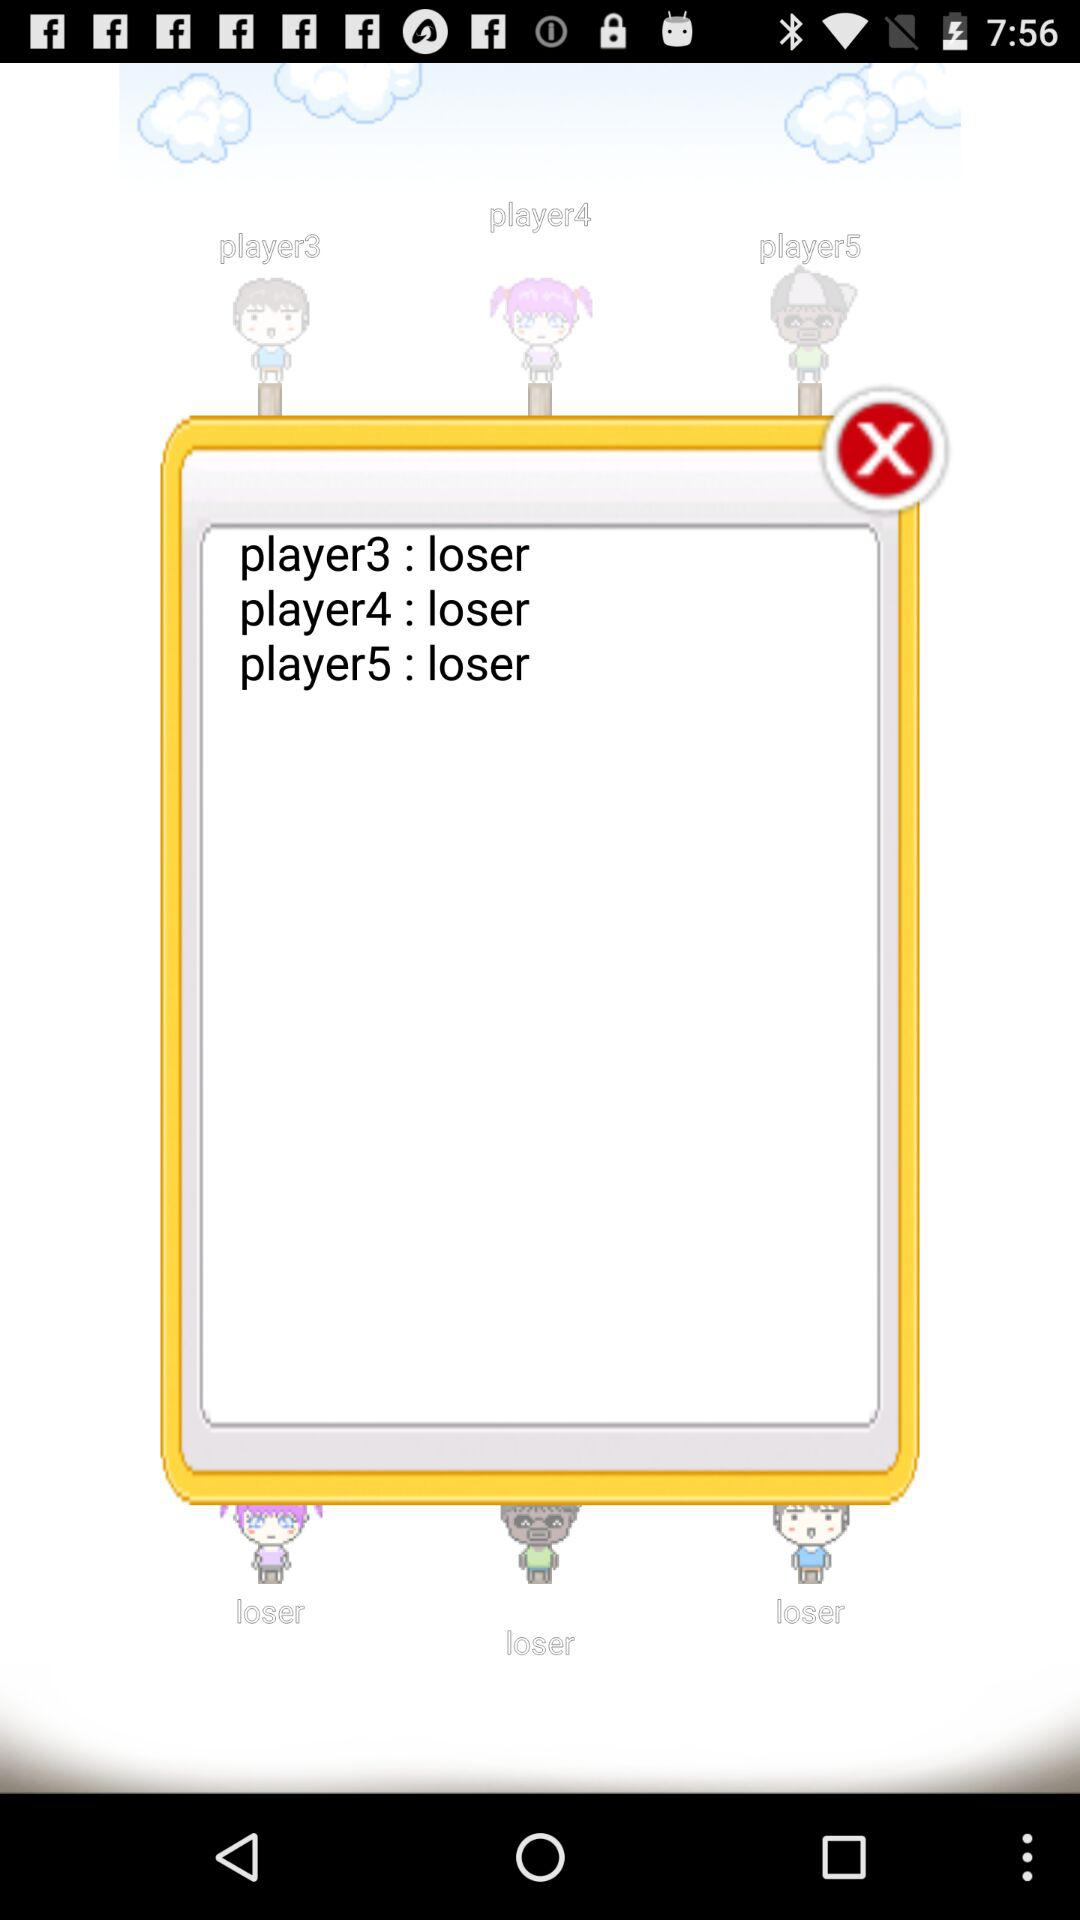How many losers are there?
Answer the question using a single word or phrase. 3 